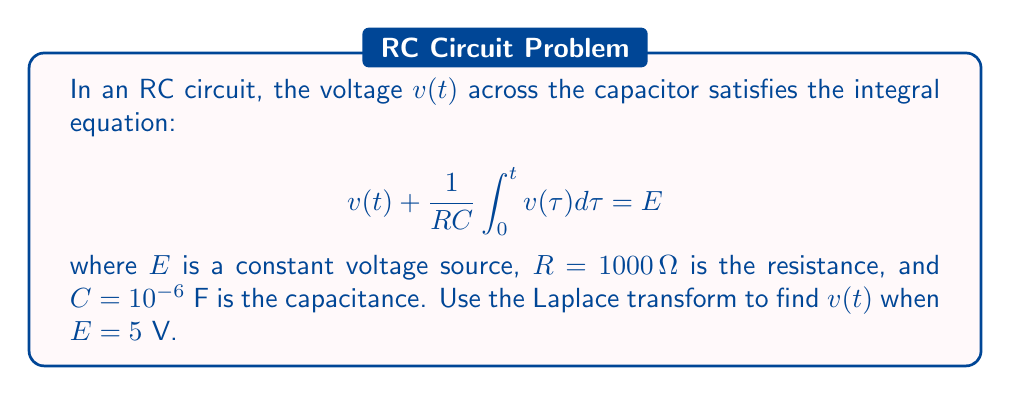Could you help me with this problem? 1) First, let's take the Laplace transform of both sides of the equation:

   $$\mathcal{L}\{v(t)\} + \frac{1}{RC}\mathcal{L}\{\int_0^t v(\tau) d\tau\} = \mathcal{L}\{E\}$$

2) Using Laplace transform properties:
   - $\mathcal{L}\{v(t)\} = V(s)$
   - $\mathcal{L}\{\int_0^t v(\tau) d\tau\} = \frac{1}{s}V(s)$
   - $\mathcal{L}\{E\} = \frac{E}{s}$ (constant)

   We get:

   $$V(s) + \frac{1}{RC} \cdot \frac{1}{s}V(s) = \frac{E}{s}$$

3) Factor out $V(s)$:

   $$V(s)(1 + \frac{1}{RCs}) = \frac{E}{s}$$

4) Solve for $V(s)$:

   $$V(s) = \frac{E}{s(1 + \frac{1}{RCs})} = \frac{E}{s + \frac{1}{RC}}$$

5) Substitute the given values:
   $R = 1000 \Omega$, $C = 10^{-6}$ F, $E = 5$ V

   $$V(s) = \frac{5}{s + 1000}$$

6) This is in the form of $\frac{A}{s+a}$, which has the inverse Laplace transform $Ae^{-at}$.

7) Therefore, the inverse Laplace transform gives us:

   $$v(t) = 5e^{-1000t}$$

This is the voltage across the capacitor as a function of time.
Answer: $v(t) = 5e^{-1000t}$ V 